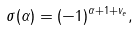<formula> <loc_0><loc_0><loc_500><loc_500>\sigma ( \alpha ) = ( - 1 ) ^ { \alpha + 1 + v _ { e } } ,</formula> 